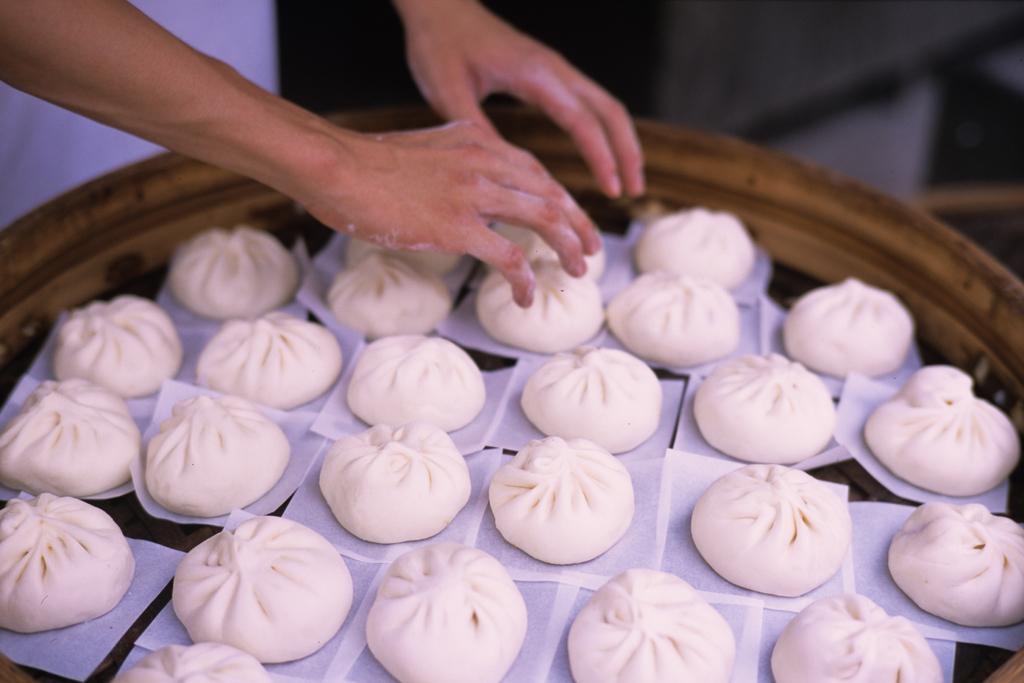What type of food is visible on the tray in the image? There are momos placed on a tray in the image. Can you describe the person on the left side of the image? Unfortunately, the provided facts do not give any information about the person on the left side of the image. What is the person's wealth status in the image? There is no information about the person's wealth status in the image, as the provided facts do not give any details about the person. 